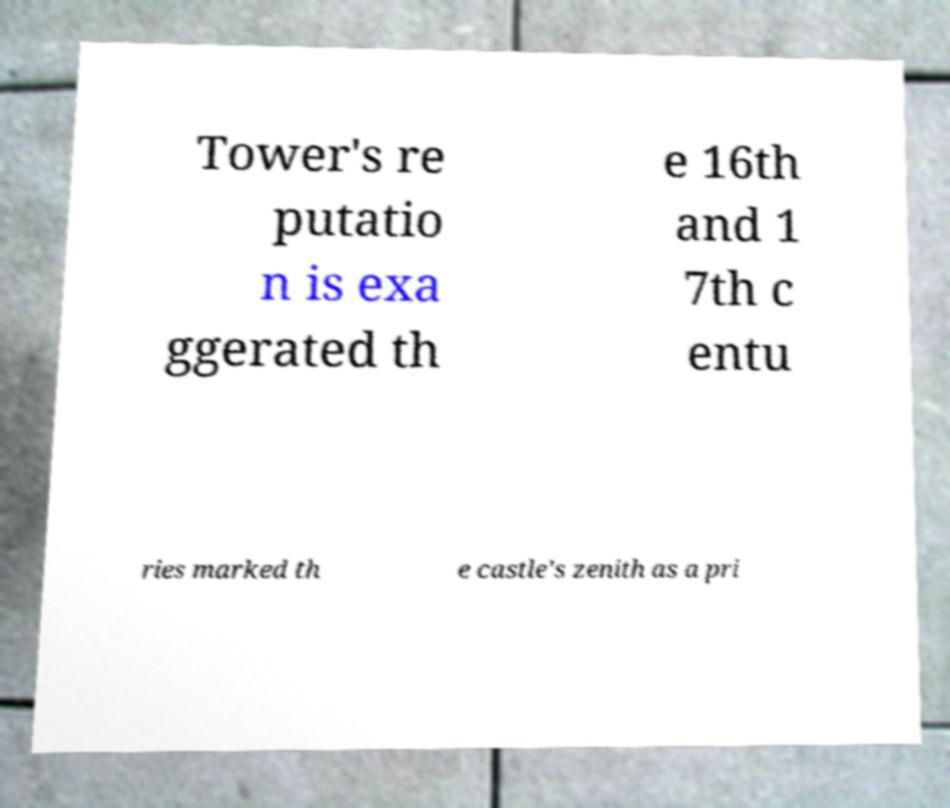Can you read and provide the text displayed in the image?This photo seems to have some interesting text. Can you extract and type it out for me? Tower's re putatio n is exa ggerated th e 16th and 1 7th c entu ries marked th e castle's zenith as a pri 